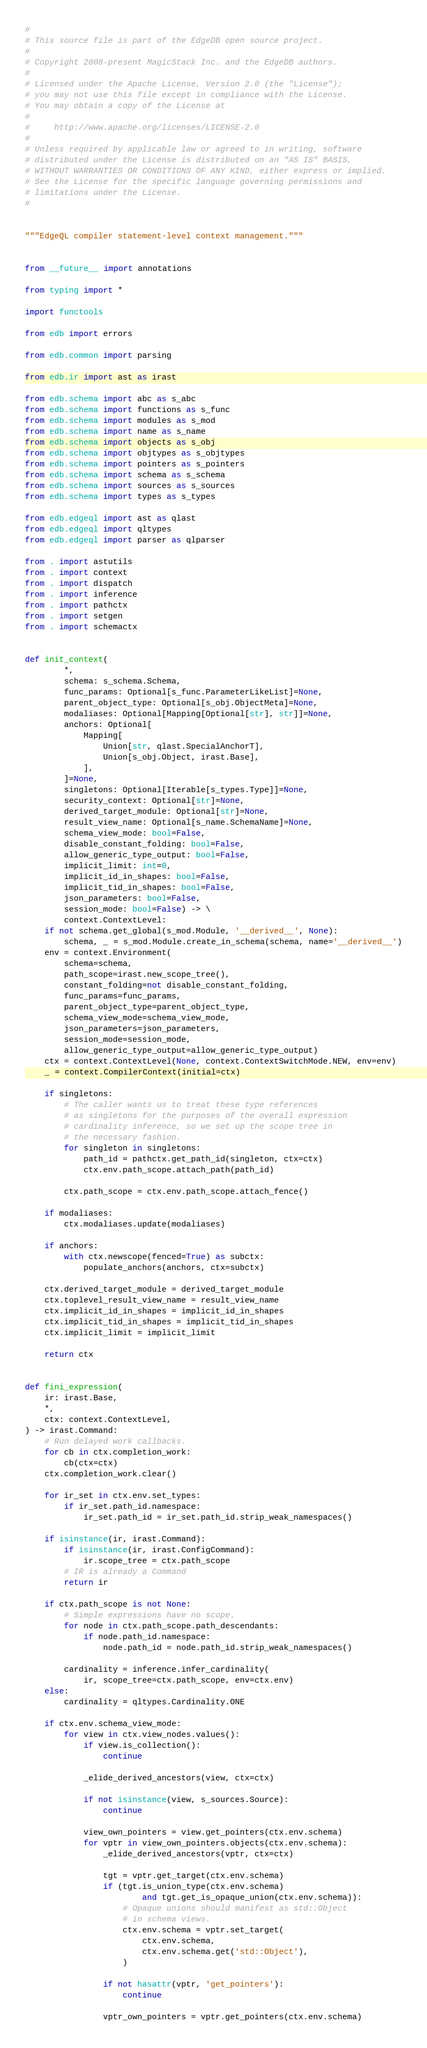<code> <loc_0><loc_0><loc_500><loc_500><_Python_>#
# This source file is part of the EdgeDB open source project.
#
# Copyright 2008-present MagicStack Inc. and the EdgeDB authors.
#
# Licensed under the Apache License, Version 2.0 (the "License");
# you may not use this file except in compliance with the License.
# You may obtain a copy of the License at
#
#     http://www.apache.org/licenses/LICENSE-2.0
#
# Unless required by applicable law or agreed to in writing, software
# distributed under the License is distributed on an "AS IS" BASIS,
# WITHOUT WARRANTIES OR CONDITIONS OF ANY KIND, either express or implied.
# See the License for the specific language governing permissions and
# limitations under the License.
#


"""EdgeQL compiler statement-level context management."""


from __future__ import annotations

from typing import *

import functools

from edb import errors

from edb.common import parsing

from edb.ir import ast as irast

from edb.schema import abc as s_abc
from edb.schema import functions as s_func
from edb.schema import modules as s_mod
from edb.schema import name as s_name
from edb.schema import objects as s_obj
from edb.schema import objtypes as s_objtypes
from edb.schema import pointers as s_pointers
from edb.schema import schema as s_schema
from edb.schema import sources as s_sources
from edb.schema import types as s_types

from edb.edgeql import ast as qlast
from edb.edgeql import qltypes
from edb.edgeql import parser as qlparser

from . import astutils
from . import context
from . import dispatch
from . import inference
from . import pathctx
from . import setgen
from . import schemactx


def init_context(
        *,
        schema: s_schema.Schema,
        func_params: Optional[s_func.ParameterLikeList]=None,
        parent_object_type: Optional[s_obj.ObjectMeta]=None,
        modaliases: Optional[Mapping[Optional[str], str]]=None,
        anchors: Optional[
            Mapping[
                Union[str, qlast.SpecialAnchorT],
                Union[s_obj.Object, irast.Base],
            ],
        ]=None,
        singletons: Optional[Iterable[s_types.Type]]=None,
        security_context: Optional[str]=None,
        derived_target_module: Optional[str]=None,
        result_view_name: Optional[s_name.SchemaName]=None,
        schema_view_mode: bool=False,
        disable_constant_folding: bool=False,
        allow_generic_type_output: bool=False,
        implicit_limit: int=0,
        implicit_id_in_shapes: bool=False,
        implicit_tid_in_shapes: bool=False,
        json_parameters: bool=False,
        session_mode: bool=False) -> \
        context.ContextLevel:
    if not schema.get_global(s_mod.Module, '__derived__', None):
        schema, _ = s_mod.Module.create_in_schema(schema, name='__derived__')
    env = context.Environment(
        schema=schema,
        path_scope=irast.new_scope_tree(),
        constant_folding=not disable_constant_folding,
        func_params=func_params,
        parent_object_type=parent_object_type,
        schema_view_mode=schema_view_mode,
        json_parameters=json_parameters,
        session_mode=session_mode,
        allow_generic_type_output=allow_generic_type_output)
    ctx = context.ContextLevel(None, context.ContextSwitchMode.NEW, env=env)
    _ = context.CompilerContext(initial=ctx)

    if singletons:
        # The caller wants us to treat these type references
        # as singletons for the purposes of the overall expression
        # cardinality inference, so we set up the scope tree in
        # the necessary fashion.
        for singleton in singletons:
            path_id = pathctx.get_path_id(singleton, ctx=ctx)
            ctx.env.path_scope.attach_path(path_id)

        ctx.path_scope = ctx.env.path_scope.attach_fence()

    if modaliases:
        ctx.modaliases.update(modaliases)

    if anchors:
        with ctx.newscope(fenced=True) as subctx:
            populate_anchors(anchors, ctx=subctx)

    ctx.derived_target_module = derived_target_module
    ctx.toplevel_result_view_name = result_view_name
    ctx.implicit_id_in_shapes = implicit_id_in_shapes
    ctx.implicit_tid_in_shapes = implicit_tid_in_shapes
    ctx.implicit_limit = implicit_limit

    return ctx


def fini_expression(
    ir: irast.Base,
    *,
    ctx: context.ContextLevel,
) -> irast.Command:
    # Run delayed work callbacks.
    for cb in ctx.completion_work:
        cb(ctx=ctx)
    ctx.completion_work.clear()

    for ir_set in ctx.env.set_types:
        if ir_set.path_id.namespace:
            ir_set.path_id = ir_set.path_id.strip_weak_namespaces()

    if isinstance(ir, irast.Command):
        if isinstance(ir, irast.ConfigCommand):
            ir.scope_tree = ctx.path_scope
        # IR is already a Command
        return ir

    if ctx.path_scope is not None:
        # Simple expressions have no scope.
        for node in ctx.path_scope.path_descendants:
            if node.path_id.namespace:
                node.path_id = node.path_id.strip_weak_namespaces()

        cardinality = inference.infer_cardinality(
            ir, scope_tree=ctx.path_scope, env=ctx.env)
    else:
        cardinality = qltypes.Cardinality.ONE

    if ctx.env.schema_view_mode:
        for view in ctx.view_nodes.values():
            if view.is_collection():
                continue

            _elide_derived_ancestors(view, ctx=ctx)

            if not isinstance(view, s_sources.Source):
                continue

            view_own_pointers = view.get_pointers(ctx.env.schema)
            for vptr in view_own_pointers.objects(ctx.env.schema):
                _elide_derived_ancestors(vptr, ctx=ctx)

                tgt = vptr.get_target(ctx.env.schema)
                if (tgt.is_union_type(ctx.env.schema)
                        and tgt.get_is_opaque_union(ctx.env.schema)):
                    # Opaque unions should manifest as std::Object
                    # in schema views.
                    ctx.env.schema = vptr.set_target(
                        ctx.env.schema,
                        ctx.env.schema.get('std::Object'),
                    )

                if not hasattr(vptr, 'get_pointers'):
                    continue

                vptr_own_pointers = vptr.get_pointers(ctx.env.schema)</code> 